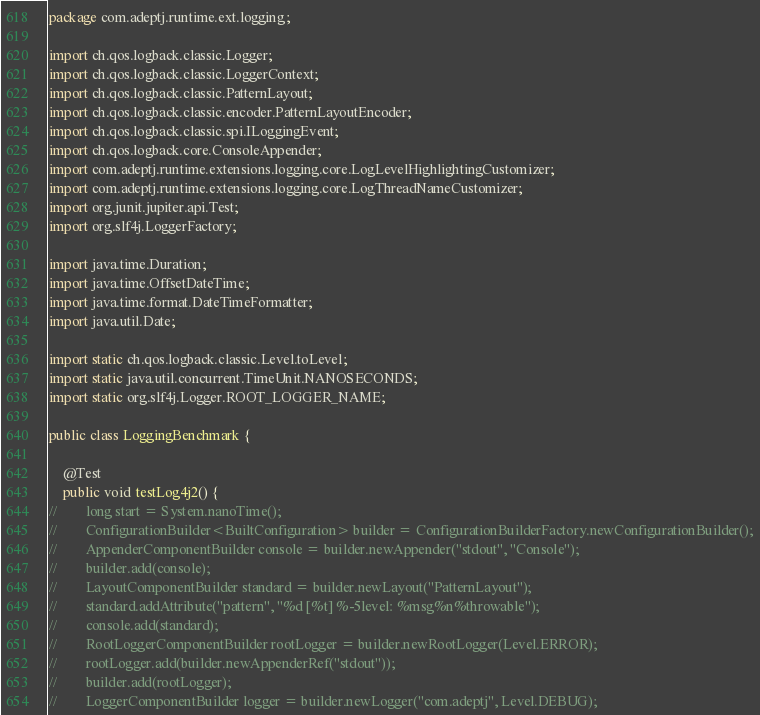<code> <loc_0><loc_0><loc_500><loc_500><_Java_>package com.adeptj.runtime.ext.logging;

import ch.qos.logback.classic.Logger;
import ch.qos.logback.classic.LoggerContext;
import ch.qos.logback.classic.PatternLayout;
import ch.qos.logback.classic.encoder.PatternLayoutEncoder;
import ch.qos.logback.classic.spi.ILoggingEvent;
import ch.qos.logback.core.ConsoleAppender;
import com.adeptj.runtime.extensions.logging.core.LogLevelHighlightingCustomizer;
import com.adeptj.runtime.extensions.logging.core.LogThreadNameCustomizer;
import org.junit.jupiter.api.Test;
import org.slf4j.LoggerFactory;

import java.time.Duration;
import java.time.OffsetDateTime;
import java.time.format.DateTimeFormatter;
import java.util.Date;

import static ch.qos.logback.classic.Level.toLevel;
import static java.util.concurrent.TimeUnit.NANOSECONDS;
import static org.slf4j.Logger.ROOT_LOGGER_NAME;

public class LoggingBenchmark {

    @Test
    public void testLog4j2() {
//        long start = System.nanoTime();
//        ConfigurationBuilder<BuiltConfiguration> builder = ConfigurationBuilderFactory.newConfigurationBuilder();
//        AppenderComponentBuilder console = builder.newAppender("stdout", "Console");
//        builder.add(console);
//        LayoutComponentBuilder standard = builder.newLayout("PatternLayout");
//        standard.addAttribute("pattern", "%d [%t] %-5level: %msg%n%throwable");
//        console.add(standard);
//        RootLoggerComponentBuilder rootLogger = builder.newRootLogger(Level.ERROR);
//        rootLogger.add(builder.newAppenderRef("stdout"));
//        builder.add(rootLogger);
//        LoggerComponentBuilder logger = builder.newLogger("com.adeptj", Level.DEBUG);</code> 